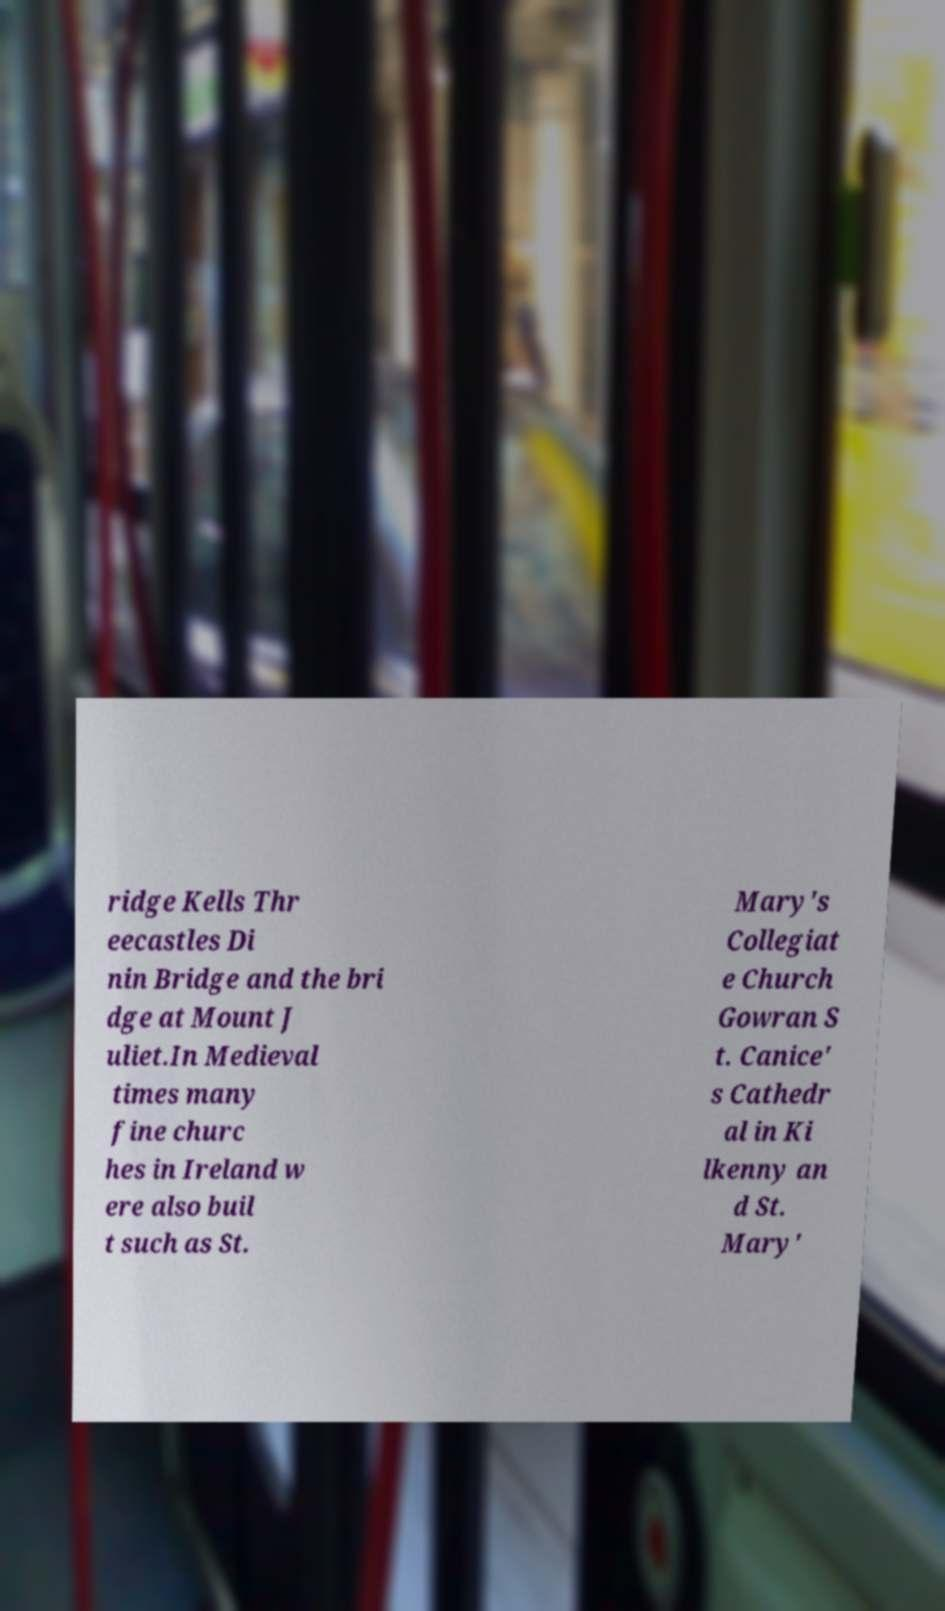Please identify and transcribe the text found in this image. ridge Kells Thr eecastles Di nin Bridge and the bri dge at Mount J uliet.In Medieval times many fine churc hes in Ireland w ere also buil t such as St. Mary's Collegiat e Church Gowran S t. Canice' s Cathedr al in Ki lkenny an d St. Mary' 